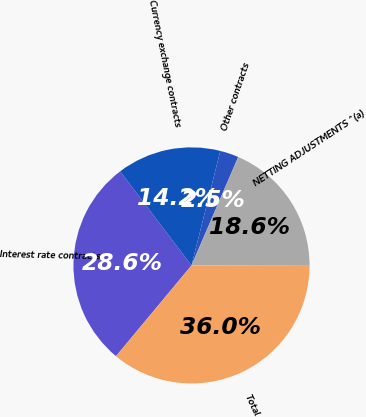<chart> <loc_0><loc_0><loc_500><loc_500><pie_chart><fcel>Interest rate contracts<fcel>Currency exchange contracts<fcel>Other contracts<fcel>NETTING ADJUSTMENTS ^(a)<fcel>Total<nl><fcel>28.63%<fcel>14.25%<fcel>2.55%<fcel>18.58%<fcel>35.99%<nl></chart> 